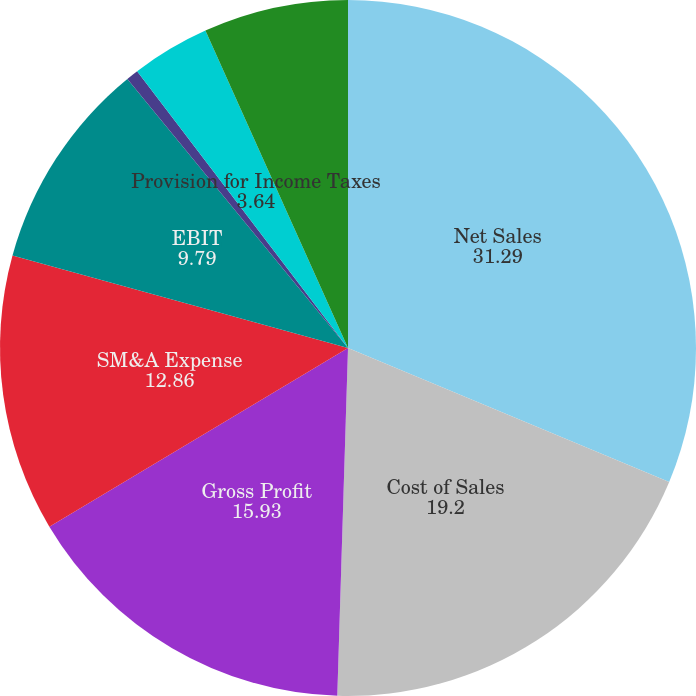Convert chart to OTSL. <chart><loc_0><loc_0><loc_500><loc_500><pie_chart><fcel>Net Sales<fcel>Cost of Sales<fcel>Gross Profit<fcel>SM&A Expense<fcel>EBIT<fcel>Interest Expense Net<fcel>Provision for Income Taxes<fcel>Net Income<nl><fcel>31.29%<fcel>19.2%<fcel>15.93%<fcel>12.86%<fcel>9.79%<fcel>0.57%<fcel>3.64%<fcel>6.72%<nl></chart> 